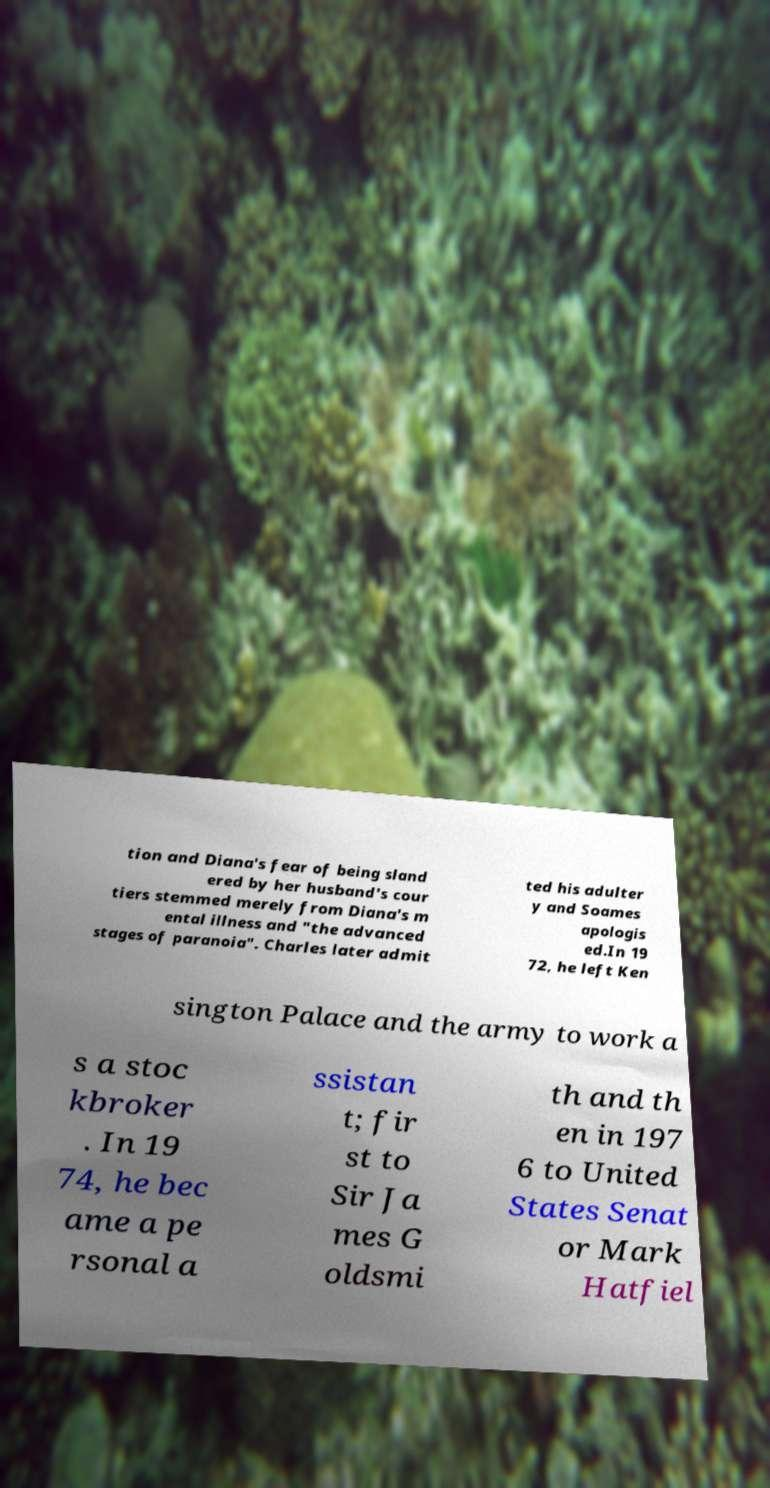Could you extract and type out the text from this image? tion and Diana's fear of being sland ered by her husband's cour tiers stemmed merely from Diana's m ental illness and "the advanced stages of paranoia". Charles later admit ted his adulter y and Soames apologis ed.In 19 72, he left Ken sington Palace and the army to work a s a stoc kbroker . In 19 74, he bec ame a pe rsonal a ssistan t; fir st to Sir Ja mes G oldsmi th and th en in 197 6 to United States Senat or Mark Hatfiel 